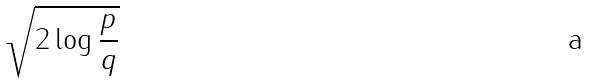Convert formula to latex. <formula><loc_0><loc_0><loc_500><loc_500>\sqrt { 2 \log \frac { p } { q } }</formula> 